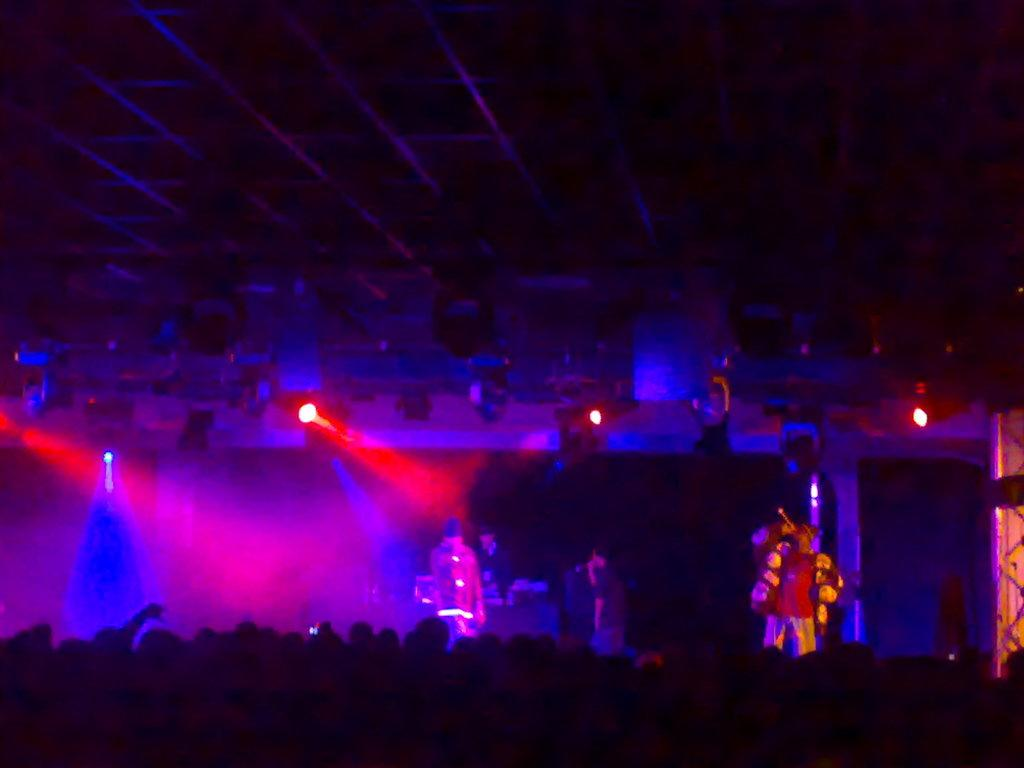Who or what can be seen in the image? There are people in the image. What is located in the background of the image? There is a stage in the background of the image. Are there any people on the stage? Yes, there are people on the stage. What can be seen in the background of the stage? Stage lighting is visible in the background of the image. Can you hear the sound of a stream in the image? There is no sound present in the image, and therefore no stream can be heard. 